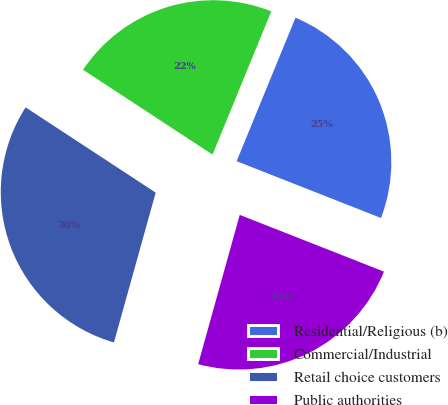<chart> <loc_0><loc_0><loc_500><loc_500><pie_chart><fcel>Residential/Religious (b)<fcel>Commercial/Industrial<fcel>Retail choice customers<fcel>Public authorities<nl><fcel>24.77%<fcel>21.96%<fcel>29.91%<fcel>23.36%<nl></chart> 